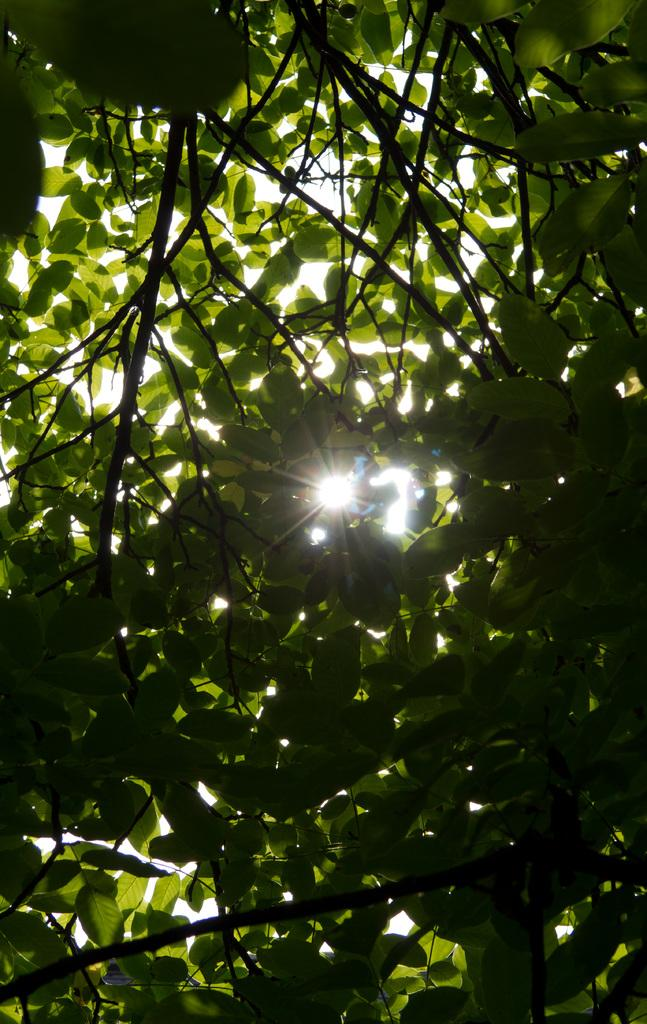What type of vegetation can be seen in the image? There are trees in the image. What is the color of the trees? The trees are green in color. What celestial body is visible in the image? The sun is visible in the image. What part of the natural environment is visible in the image? The sky is visible in the image. What type of amusement can be seen in the image? There is no amusement present in the image; it features trees, the sun, and the sky. How does the death of the trees affect the image? The trees are not dead, and their death would not affect the image, as they are green and healthy. 